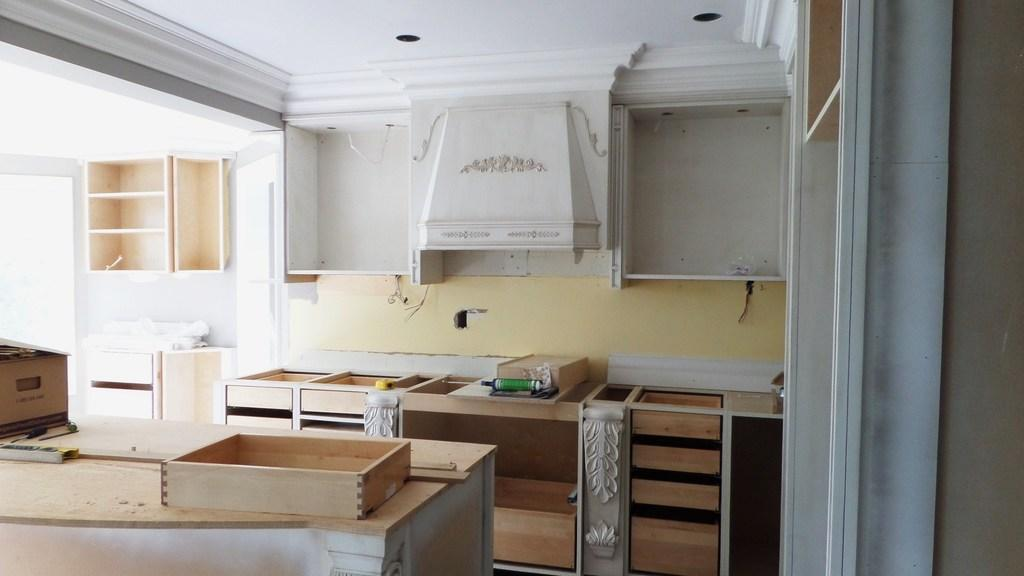What type of objects are made of wood in the image? There are wooden boxes and other wooden objects in the image. What type of furniture is present in the image? There is a cupboard in the image. What tool is visible in the image? A drilling machine is visible in the image. What type of structure is present in the image? There is a wall and a roof in the image. Can you see a stamp being used on the wooden boxes in the image? There is no stamp present or being used on the wooden boxes in the image. Is there a man performing magic tricks in the image? There is no man or magic tricks present in the image. 